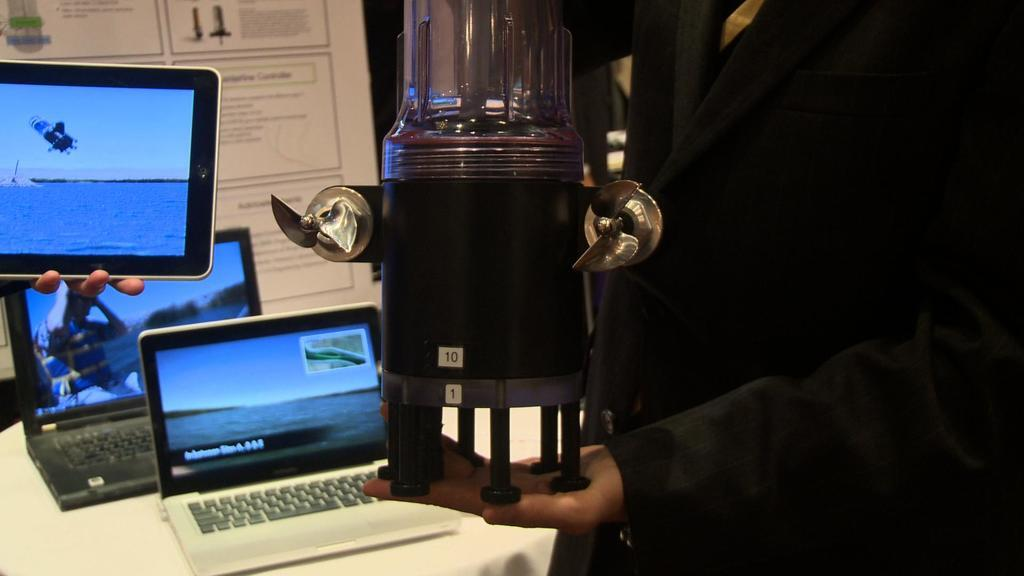Provide a one-sentence caption for the provided image. A series of small netbooks, one of them a Dell on a table. 